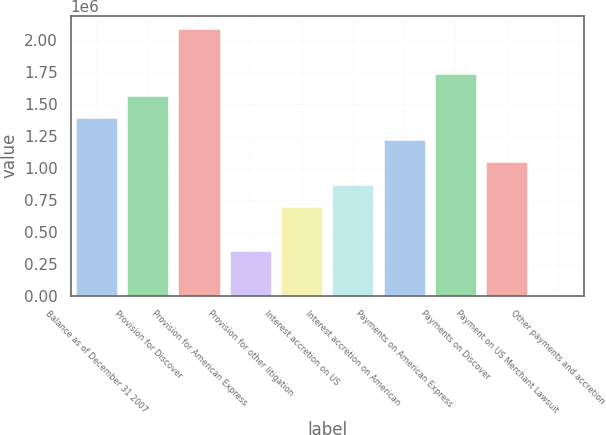Convert chart to OTSL. <chart><loc_0><loc_0><loc_500><loc_500><bar_chart><fcel>Balance as of December 31 2007<fcel>Provision for Discover<fcel>Provision for American Express<fcel>Provision for other litigation<fcel>Interest accretion on US<fcel>Interest accretion on American<fcel>Payments on American Express<fcel>Payments on Discover<fcel>Payment on US Merchant Lawsuit<fcel>Other payments and accretion<nl><fcel>1.38917e+06<fcel>1.56273e+06<fcel>2.08343e+06<fcel>347789<fcel>694916<fcel>868480<fcel>1.21561e+06<fcel>1.7363e+06<fcel>1.04204e+06<fcel>662<nl></chart> 